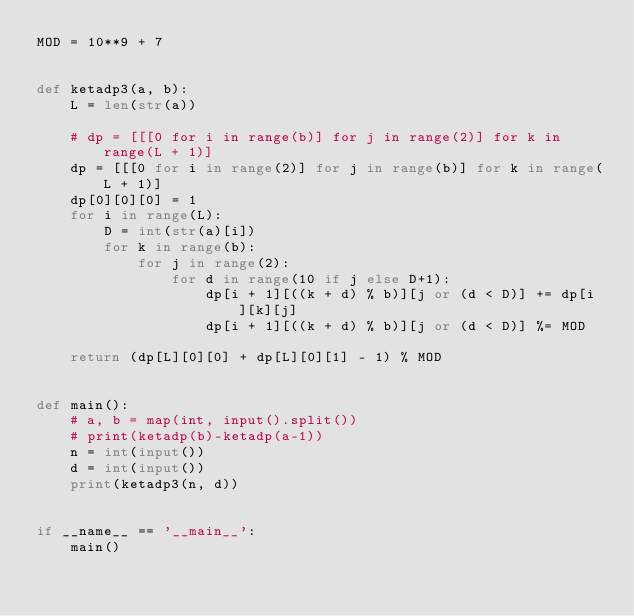<code> <loc_0><loc_0><loc_500><loc_500><_Python_>MOD = 10**9 + 7


def ketadp3(a, b):
    L = len(str(a))

    # dp = [[[0 for i in range(b)] for j in range(2)] for k in range(L + 1)]
    dp = [[[0 for i in range(2)] for j in range(b)] for k in range(L + 1)]
    dp[0][0][0] = 1
    for i in range(L):
        D = int(str(a)[i])
        for k in range(b):
            for j in range(2):
                for d in range(10 if j else D+1):
                    dp[i + 1][((k + d) % b)][j or (d < D)] += dp[i][k][j]
                    dp[i + 1][((k + d) % b)][j or (d < D)] %= MOD

    return (dp[L][0][0] + dp[L][0][1] - 1) % MOD


def main():
    # a, b = map(int, input().split())
    # print(ketadp(b)-ketadp(a-1))
    n = int(input())
    d = int(input())
    print(ketadp3(n, d))


if __name__ == '__main__':
    main()
</code> 